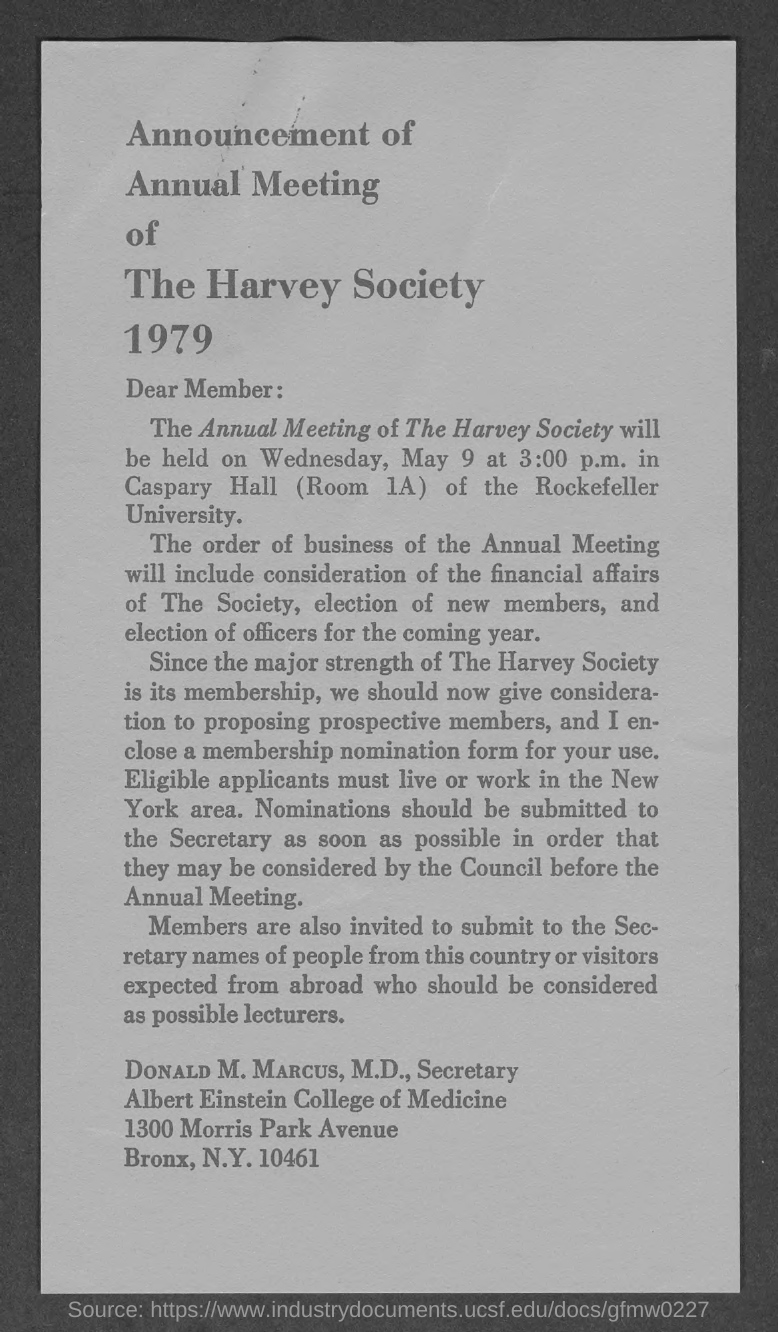Specify some key components in this picture. Donald M. Marcus, M.D. holds the designation of Secretary. The Annual Meeting of The Harvey Society will be held on Wednesday, May 9 at 3:00 p.m. The Annual Meeting of The Harvey Society is held in Caspary Hall (Room 1A) of the Rockefeller University every year. 